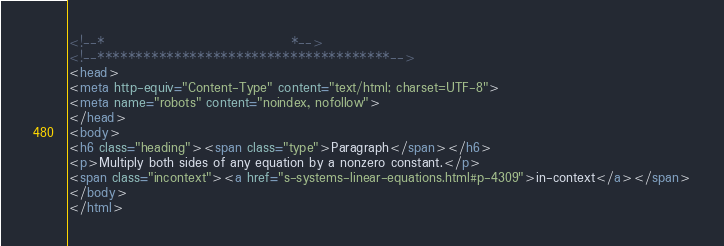Convert code to text. <code><loc_0><loc_0><loc_500><loc_500><_HTML_><!--*                                    *-->
<!--**************************************-->
<head>
<meta http-equiv="Content-Type" content="text/html; charset=UTF-8">
<meta name="robots" content="noindex, nofollow">
</head>
<body>
<h6 class="heading"><span class="type">Paragraph</span></h6>
<p>Multiply both sides of any equation by a nonzero constant.</p>
<span class="incontext"><a href="s-systems-linear-equations.html#p-4309">in-context</a></span>
</body>
</html>
</code> 